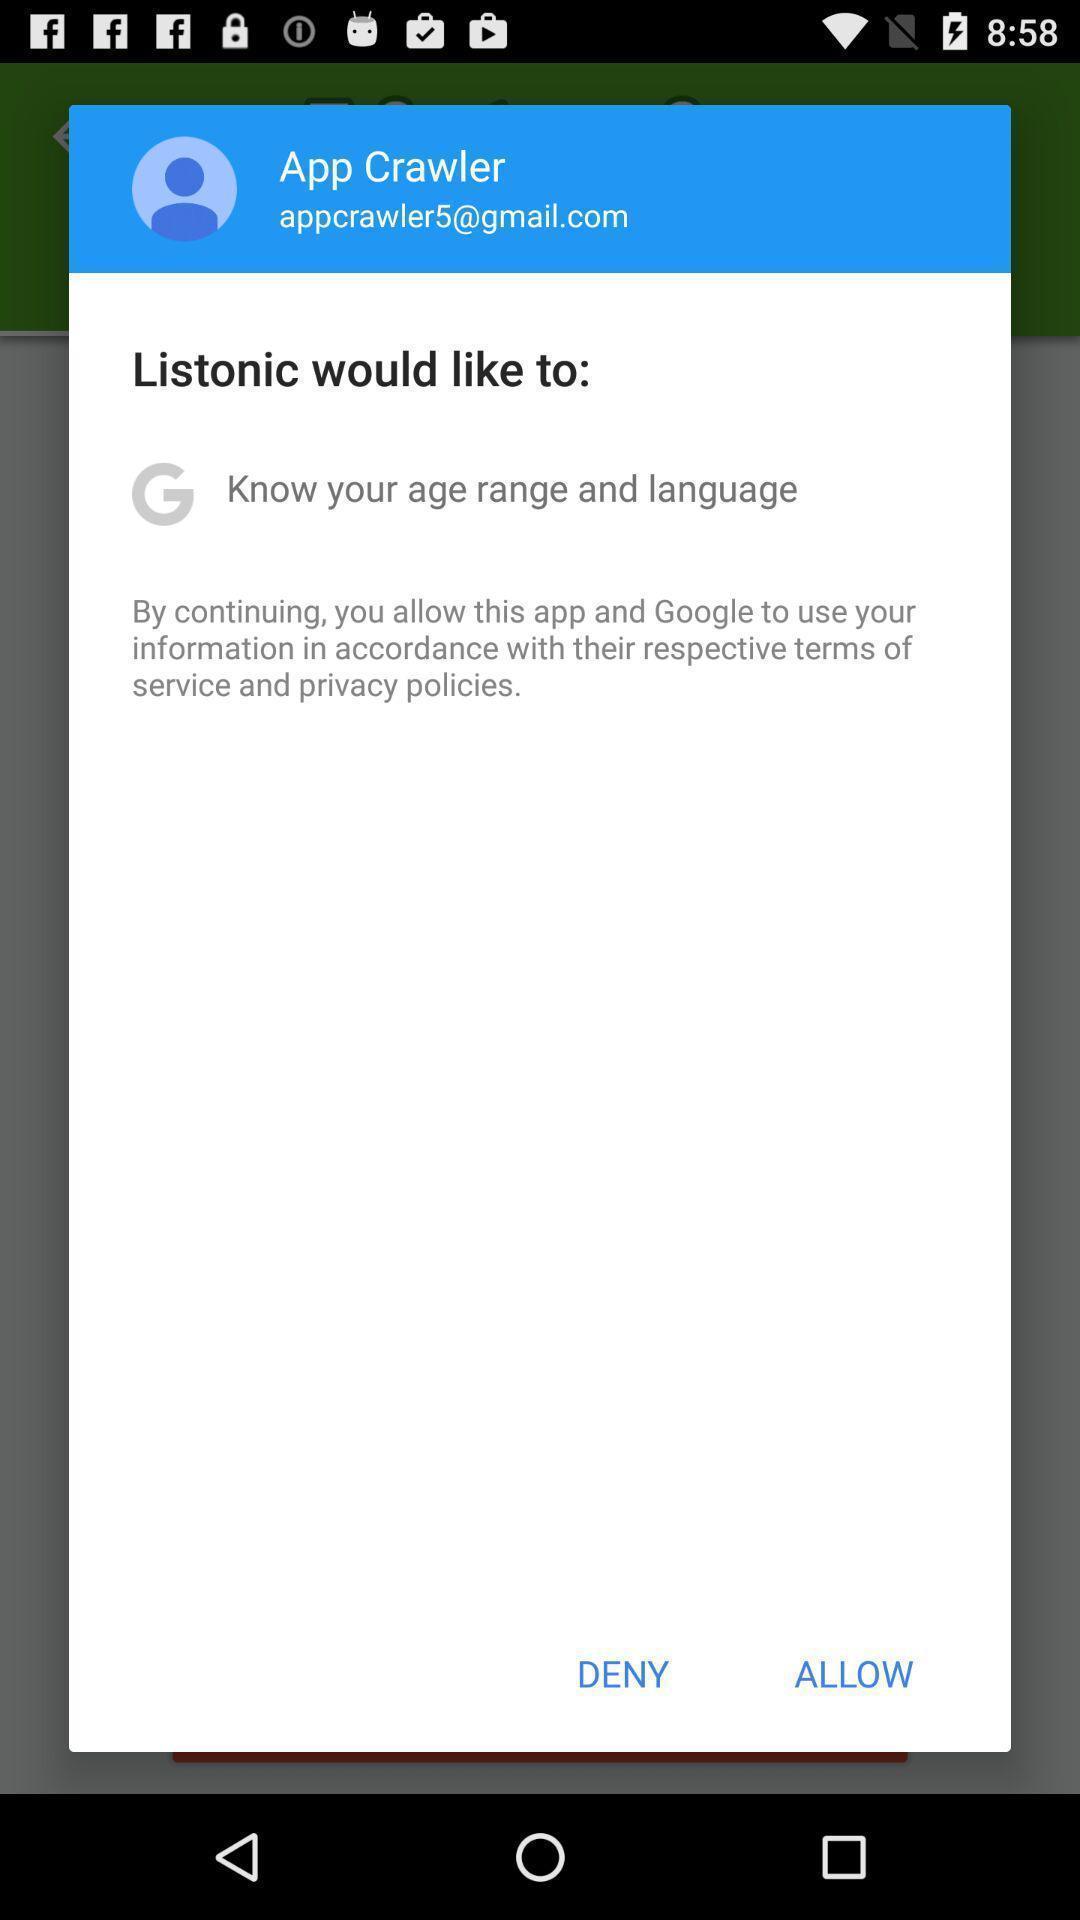Give me a summary of this screen capture. Pop-up shows allow for the application. 